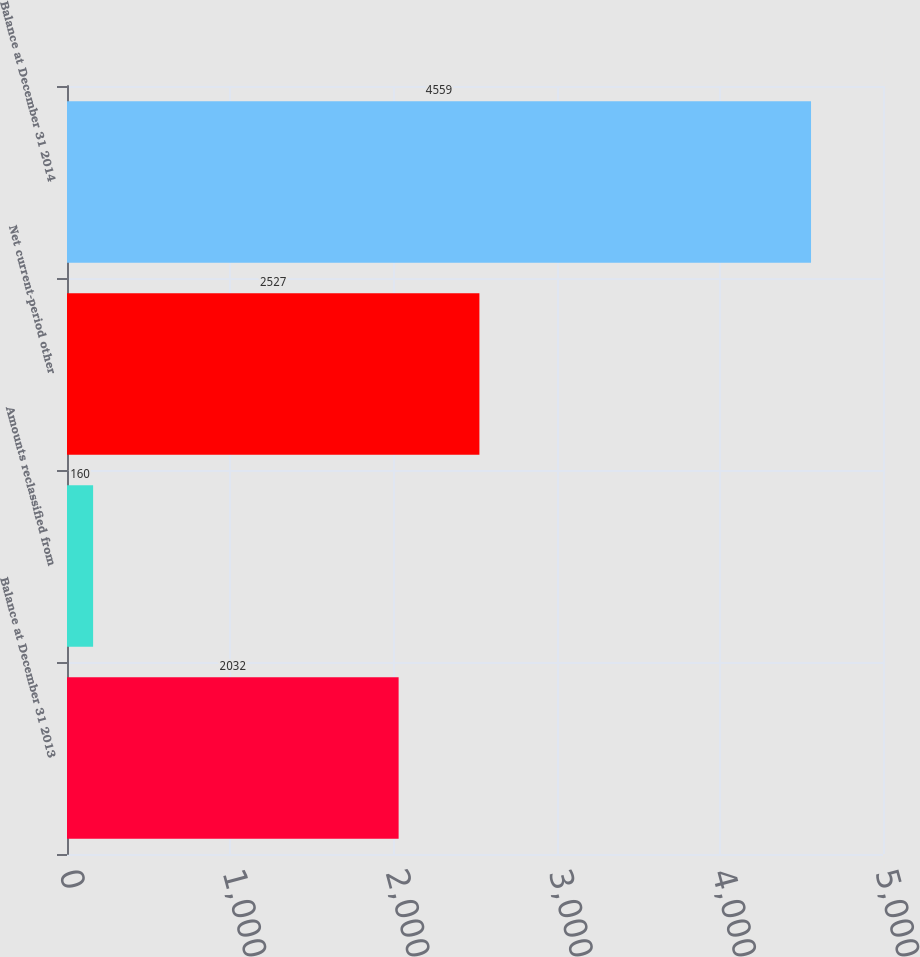<chart> <loc_0><loc_0><loc_500><loc_500><bar_chart><fcel>Balance at December 31 2013<fcel>Amounts reclassified from<fcel>Net current-period other<fcel>Balance at December 31 2014<nl><fcel>2032<fcel>160<fcel>2527<fcel>4559<nl></chart> 